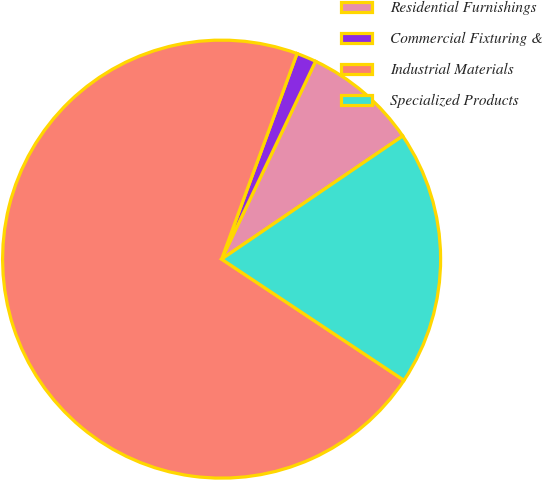Convert chart to OTSL. <chart><loc_0><loc_0><loc_500><loc_500><pie_chart><fcel>Residential Furnishings<fcel>Commercial Fixturing &<fcel>Industrial Materials<fcel>Specialized Products<nl><fcel>8.44%<fcel>1.46%<fcel>71.26%<fcel>18.84%<nl></chart> 